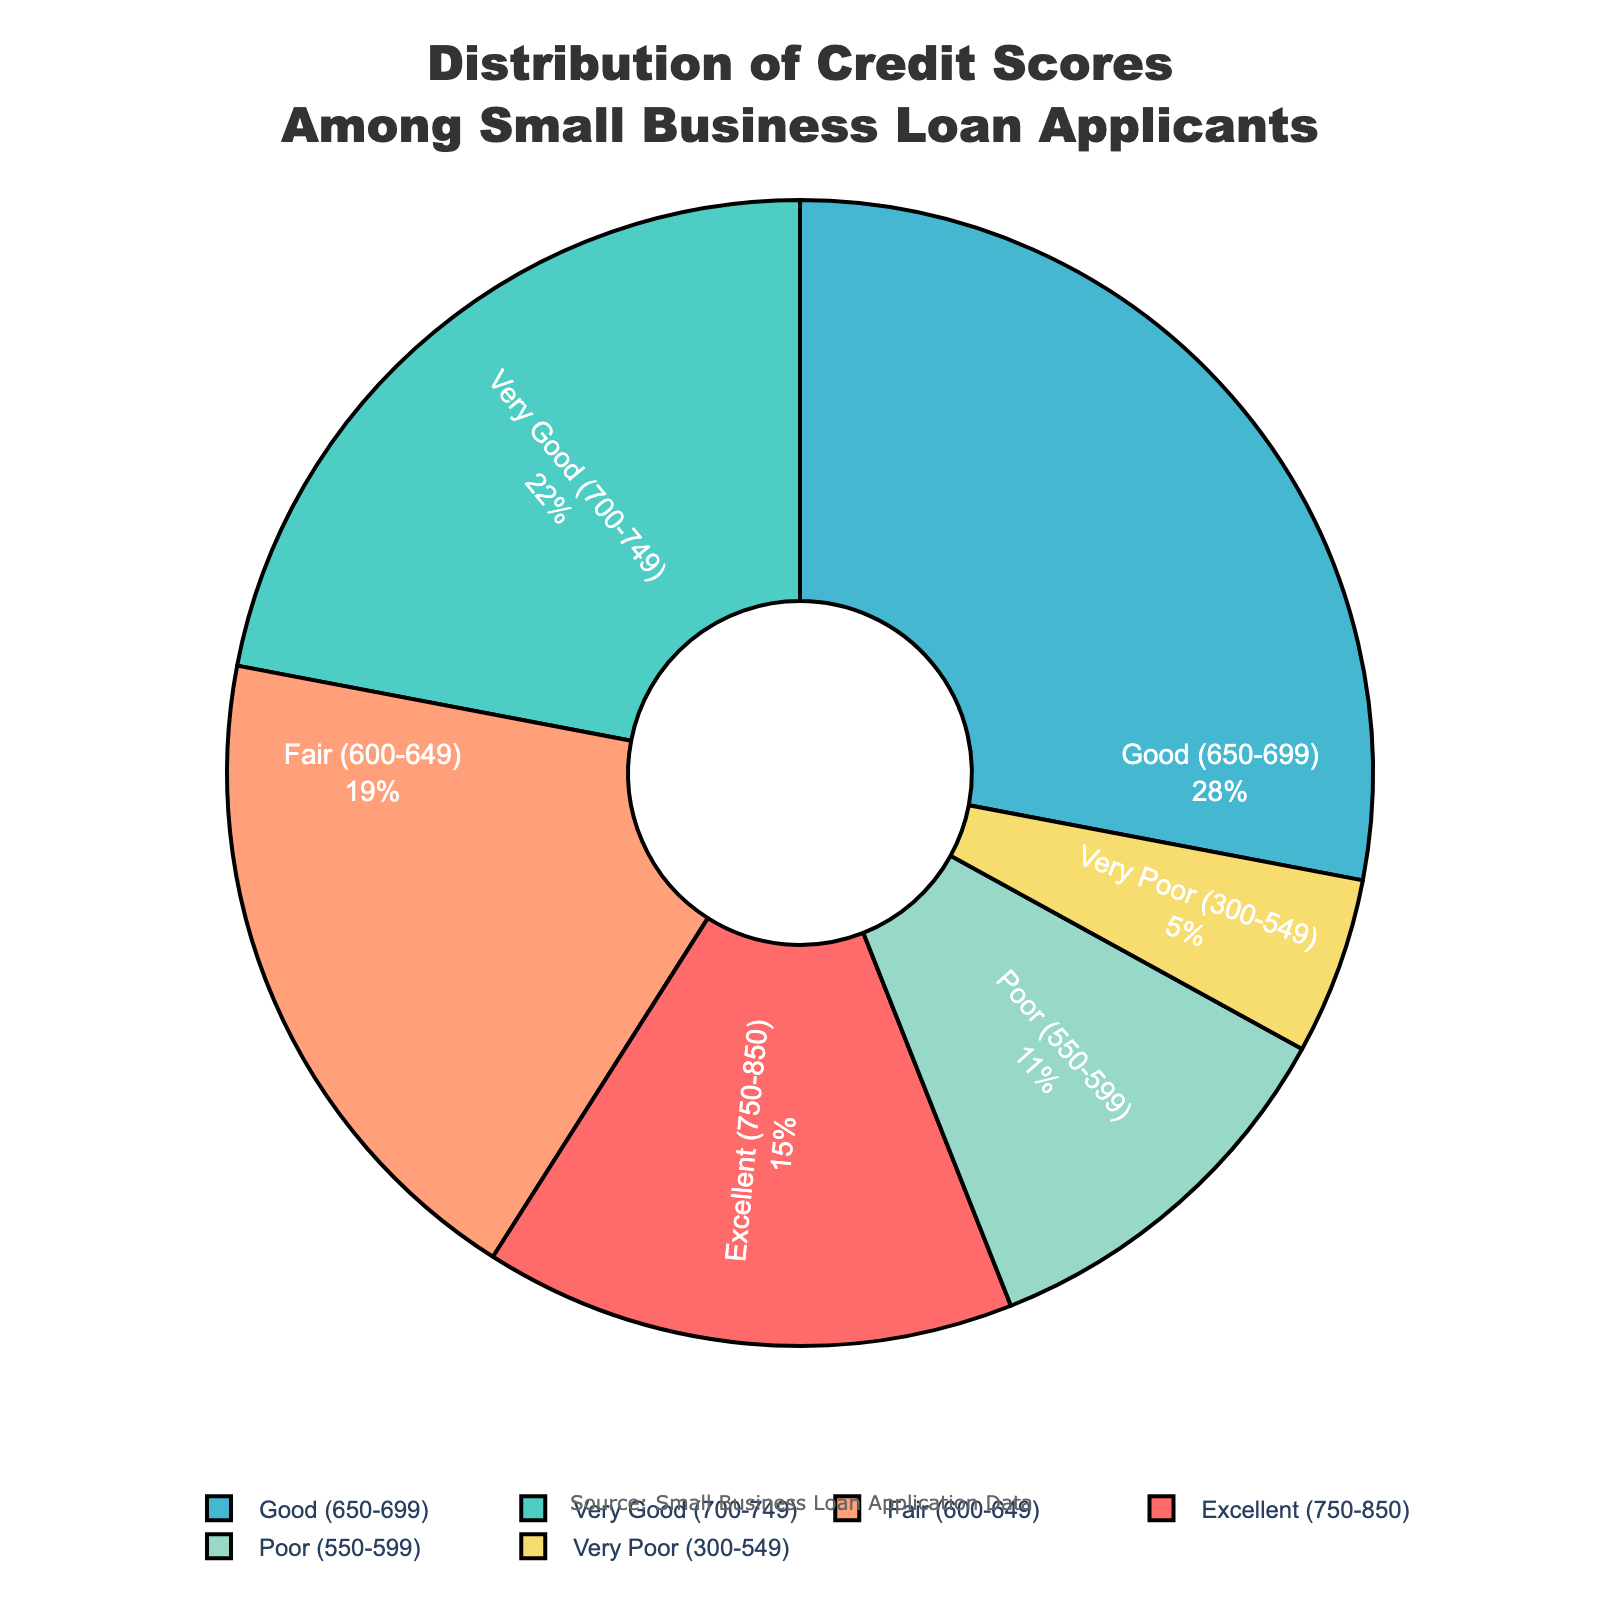what percentage of applicants have a credit score of at least 700? To find the percentage of applicants with a credit score of at least 700, we need to sum the percentages of those in the "Excellent (750-850)" and "Very Good (700-749)" categories. Adding 15% (Excellent) and 22% (Very Good) gives us 37%.
Answer: 37% Which credit score range has the largest percentage of applicants? By examining the pie chart, we see that the "Good (650-699)" segment is the largest, making up 28% of the applicants.
Answer: Good (650-699) What percentage of applicants have a credit score below 600? To find the percentage of applicants with a credit score below 600, we need to sum the percentages of those in the "Poor (550-599)" and "Very Poor (300-549)" categories. Adding 11% (Poor) and 5% (Very Poor) gives us 16%.
Answer: 16% Is the percentage of applicants with a "Fair" credit score higher or lower than that of those with an "Excellent" credit score? The percentage of applicants with a "Fair" credit score is 19%, while those with an "Excellent" credit score make up 15%. Therefore, the "Fair" percentage is higher.
Answer: Higher What's the difference in percentage between applicants with "Good" credit scores and those with "Fair" credit scores? The "Good (650-699)" category has 28%, and the "Fair (600-649)" category has 19%. The difference is found by subtracting 19% from 28%, which equals 9%.
Answer: 9% How much higher is the percentage of "Very Good" credit scores compared to "Poor" credit scores? The "Very Good (700-749)" category has 22%, and the "Poor (550-599)" category has 11%. The difference is calculated by subtracting 11% from 22%, which equals 11%.
Answer: 11% What fraction of the total applicants fall into the "Excellent" and "Very Poor" credit score categories combined? To find this fraction, we add the percentages of "Excellent (750-850)" and "Very Poor (300-549)" categories, which are 15% and 5% respectively, giving us 20%. This converts to the fraction 20/100 or 1/5 of the total.
Answer: 1/5 Is the color representing "Fair" credit scores darker or lighter than the color for "Poor" credit scores? Visually, the "Poor (550-599)" segment is represented in a red/dark color, whereas the "Fair (600-649)" segment is depicted in a lighter shade, such as a light orange.
Answer: Lighter 